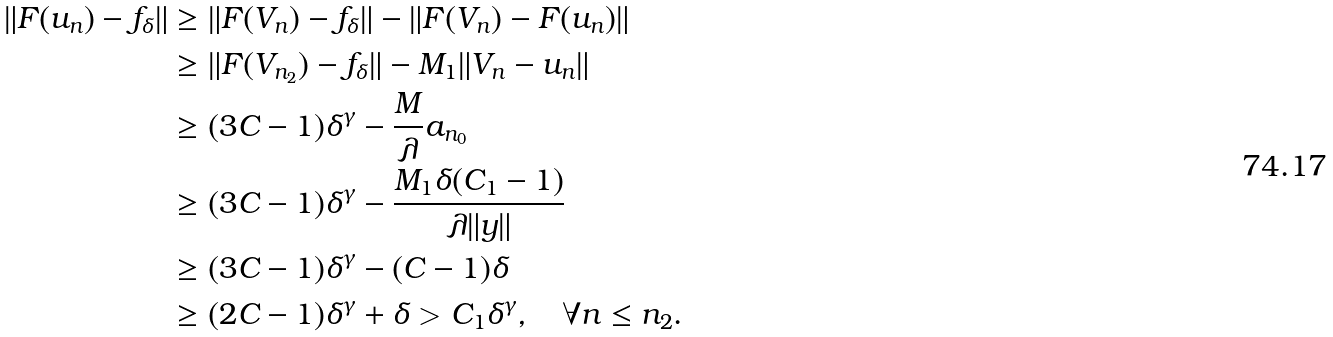Convert formula to latex. <formula><loc_0><loc_0><loc_500><loc_500>\| F ( u _ { n } ) - f _ { \delta } \| & \geq \| F ( V _ { n } ) - f _ { \delta } \| - \| F ( V _ { n } ) - F ( u _ { n } ) \| \\ & \geq \| F ( V _ { n _ { 2 } } ) - f _ { \delta } \| - M _ { 1 } \| V _ { n } - u _ { n } \| \\ & \geq ( 3 C - 1 ) \delta ^ { \gamma } - \frac { M } { \lambda } a _ { n _ { 0 } } \\ & \geq ( 3 C - 1 ) \delta ^ { \gamma } - \frac { M _ { 1 } \delta ( C _ { 1 } - 1 ) } { \lambda \| y \| } \\ & \geq ( 3 C - 1 ) \delta ^ { \gamma } - ( C - 1 ) \delta \\ & \geq ( 2 C - 1 ) \delta ^ { \gamma } + \delta > C _ { 1 } \delta ^ { \gamma } , \quad \forall n \leq n _ { 2 } .</formula> 